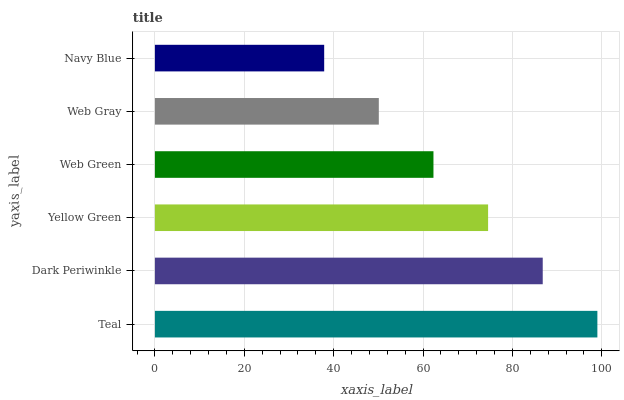Is Navy Blue the minimum?
Answer yes or no. Yes. Is Teal the maximum?
Answer yes or no. Yes. Is Dark Periwinkle the minimum?
Answer yes or no. No. Is Dark Periwinkle the maximum?
Answer yes or no. No. Is Teal greater than Dark Periwinkle?
Answer yes or no. Yes. Is Dark Periwinkle less than Teal?
Answer yes or no. Yes. Is Dark Periwinkle greater than Teal?
Answer yes or no. No. Is Teal less than Dark Periwinkle?
Answer yes or no. No. Is Yellow Green the high median?
Answer yes or no. Yes. Is Web Green the low median?
Answer yes or no. Yes. Is Teal the high median?
Answer yes or no. No. Is Navy Blue the low median?
Answer yes or no. No. 